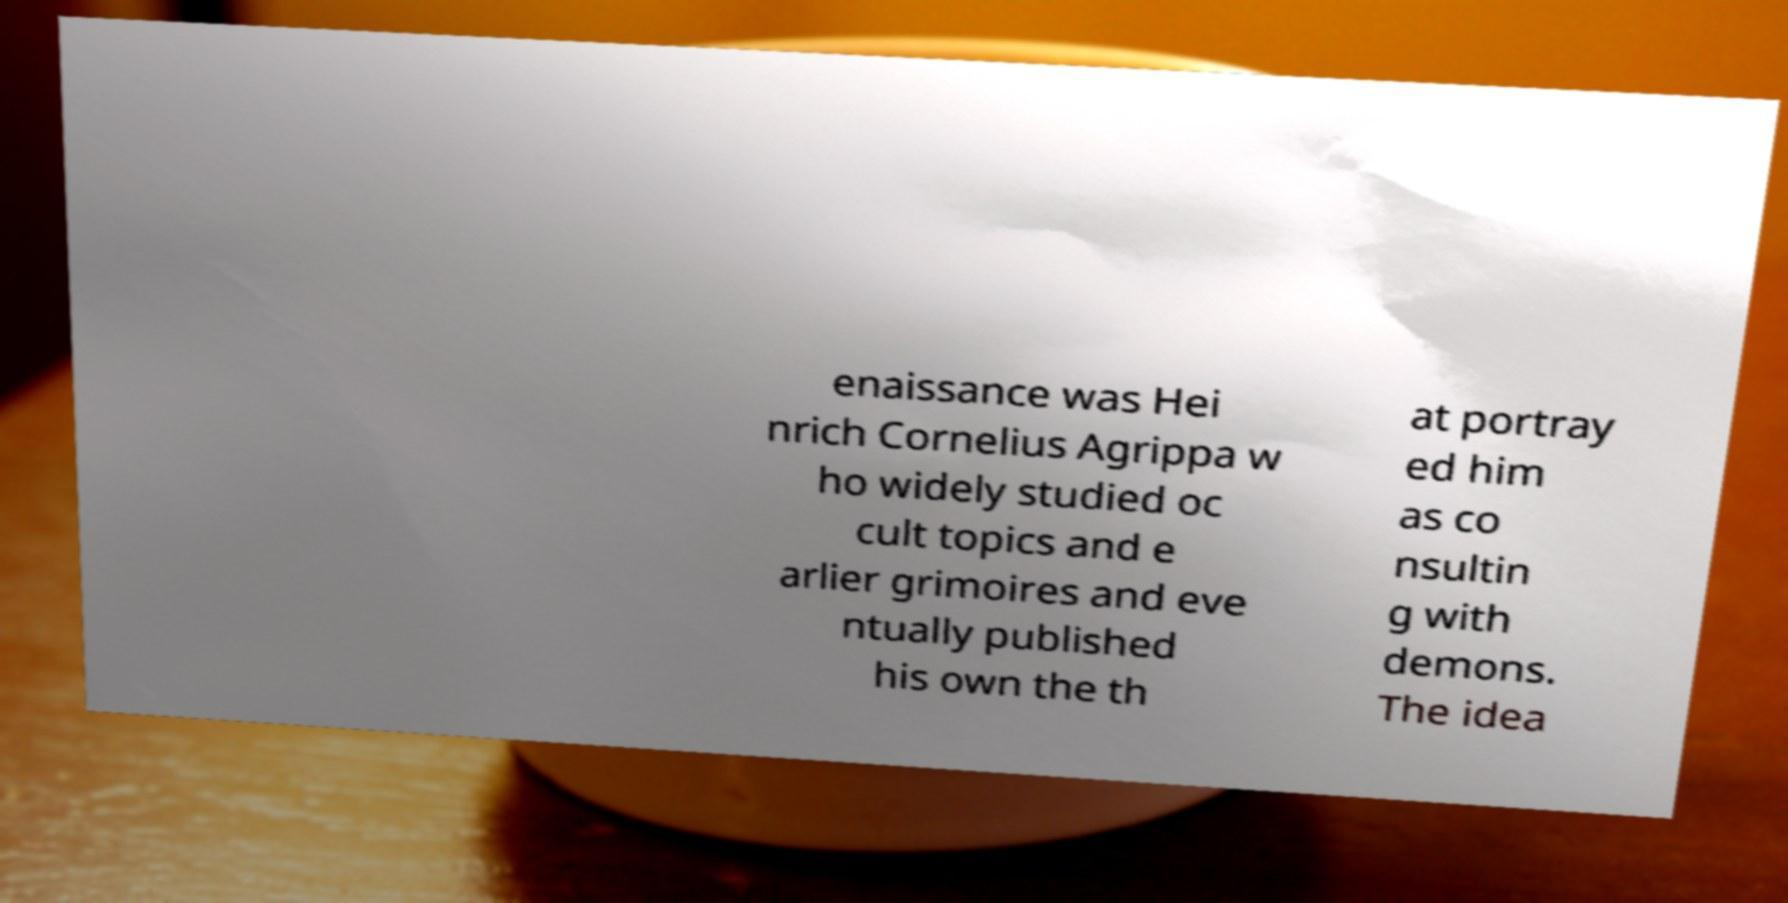What messages or text are displayed in this image? I need them in a readable, typed format. enaissance was Hei nrich Cornelius Agrippa w ho widely studied oc cult topics and e arlier grimoires and eve ntually published his own the th at portray ed him as co nsultin g with demons. The idea 